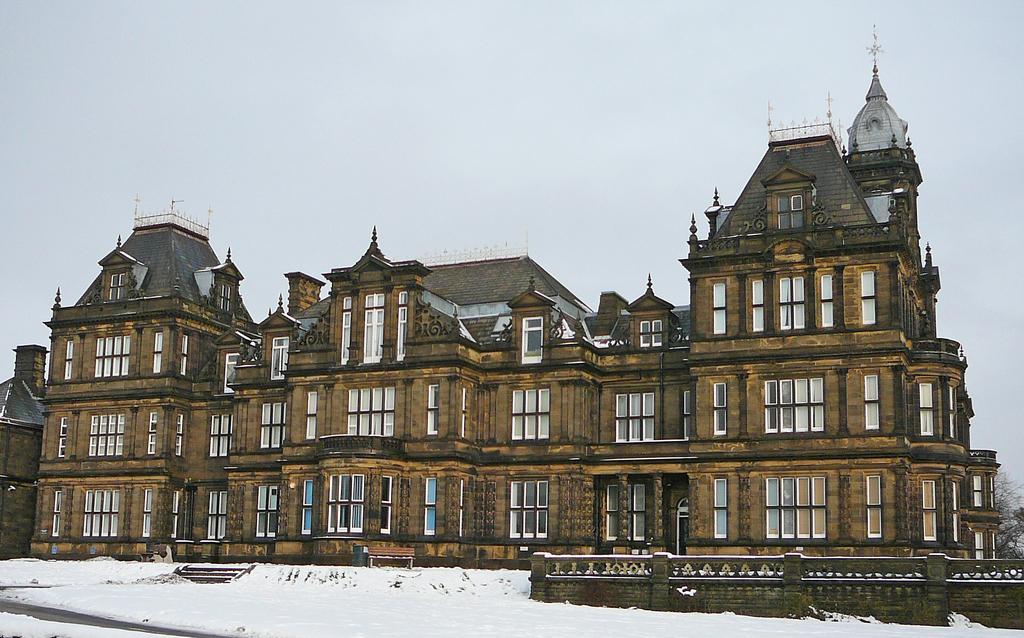In one or two sentences, can you explain what this image depicts? In this image we can see a building with windows. On the ground there is snow. Also there is a wall. In the background there is sky. 